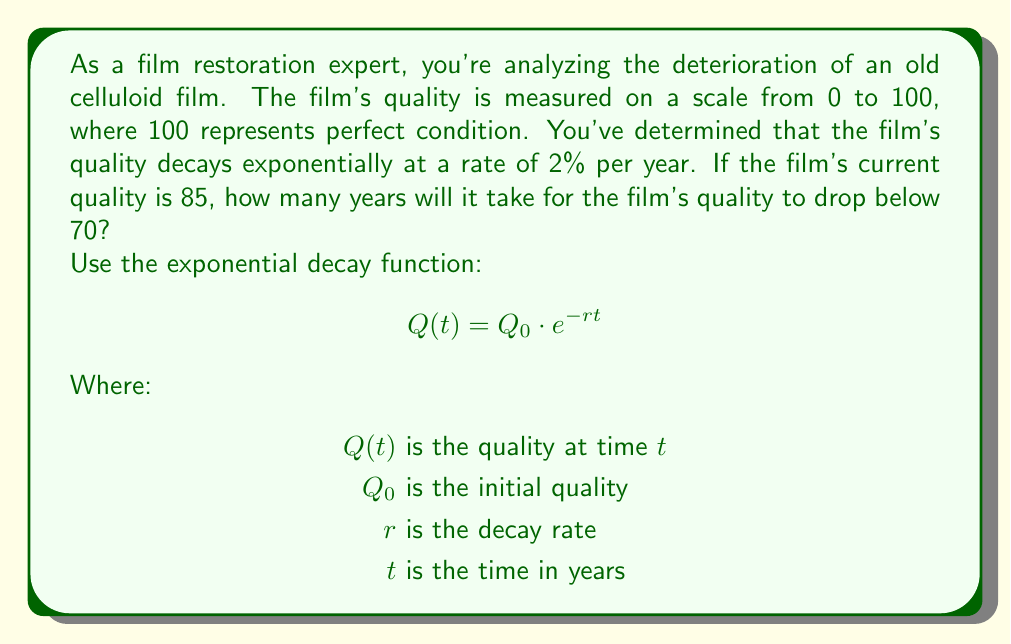Could you help me with this problem? To solve this problem, we'll use the exponential decay function and solve for $t$.

Given:
- Initial quality $Q_0 = 85$
- Decay rate $r = 0.02$ (2% per year)
- Final quality $Q(t) = 70$

Step 1: Set up the equation
$$70 = 85 \cdot e^{-0.02t}$$

Step 2: Divide both sides by 85
$$\frac{70}{85} = e^{-0.02t}$$

Step 3: Take the natural logarithm of both sides
$$\ln(\frac{70}{85}) = \ln(e^{-0.02t})$$
$$\ln(\frac{70}{85}) = -0.02t$$

Step 4: Solve for $t$
$$t = -\frac{\ln(\frac{70}{85})}{0.02}$$

Step 5: Calculate the result
$$t = -\frac{\ln(0.8235)}{0.02} \approx 9.67 \text{ years}$$

Since we're looking for the time when the quality drops below 70, we need to round up to the next whole year.
Answer: It will take 10 years for the film's quality to drop below 70. 